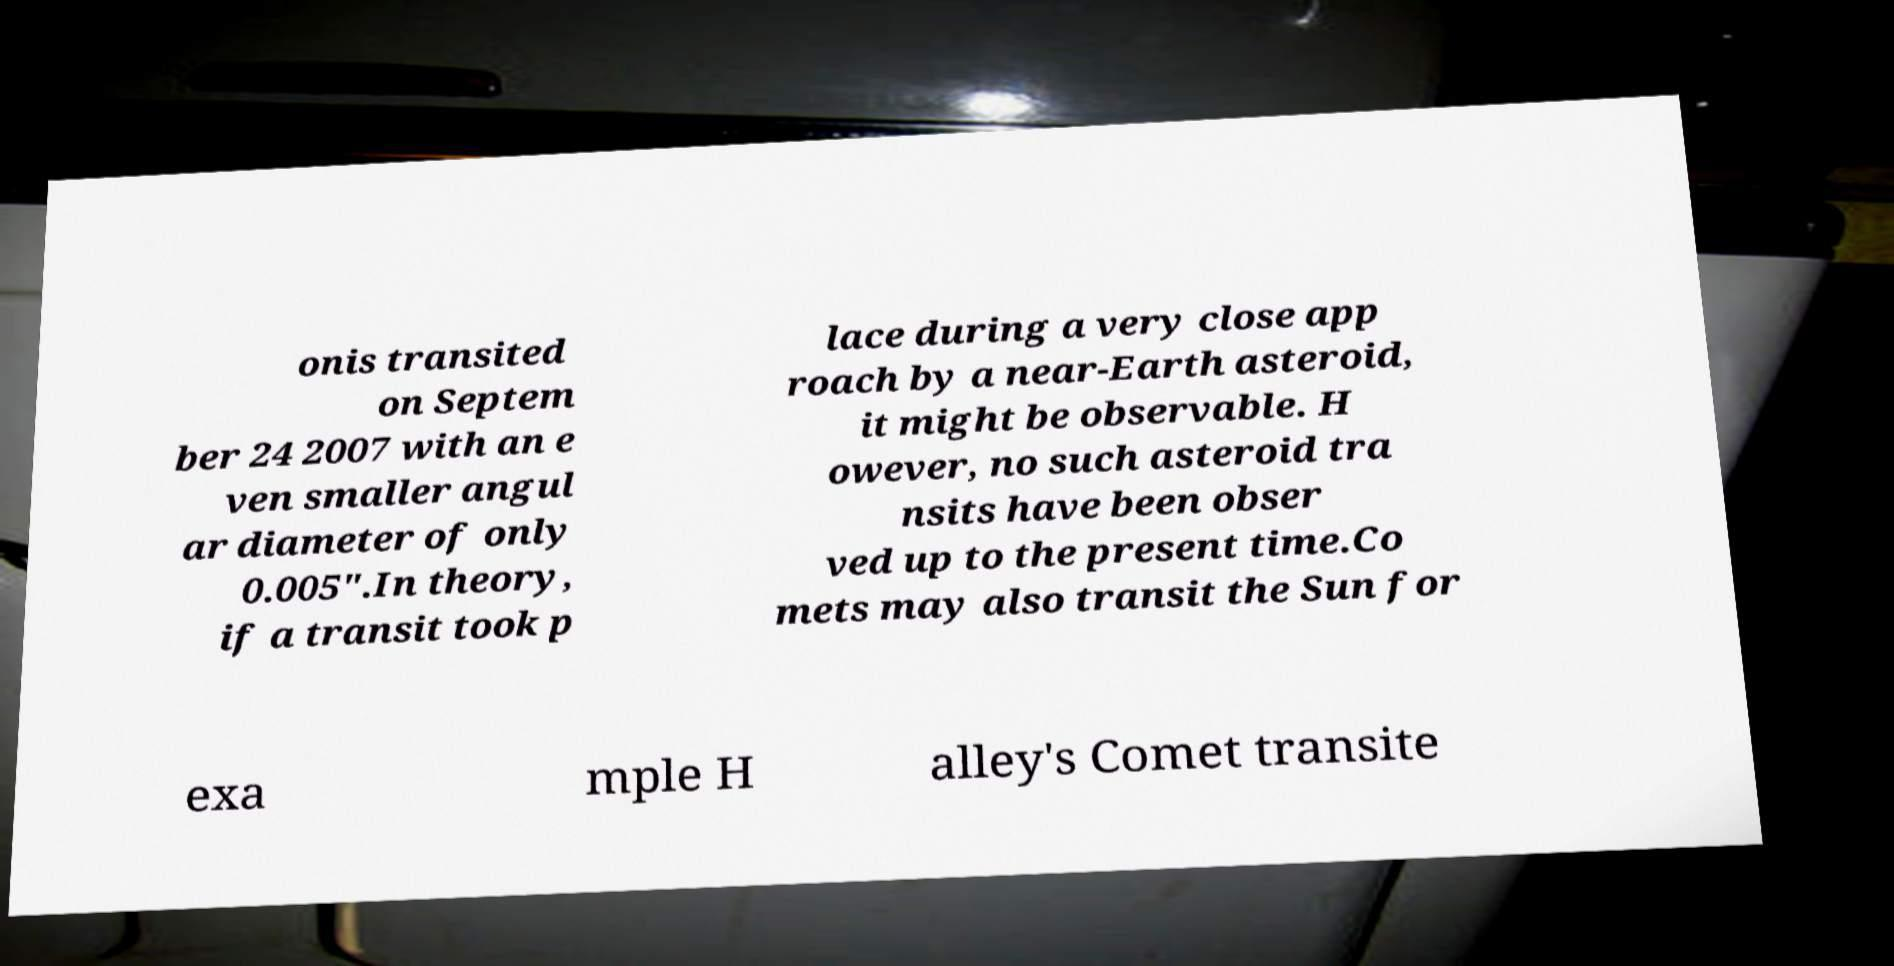I need the written content from this picture converted into text. Can you do that? onis transited on Septem ber 24 2007 with an e ven smaller angul ar diameter of only 0.005″.In theory, if a transit took p lace during a very close app roach by a near-Earth asteroid, it might be observable. H owever, no such asteroid tra nsits have been obser ved up to the present time.Co mets may also transit the Sun for exa mple H alley's Comet transite 